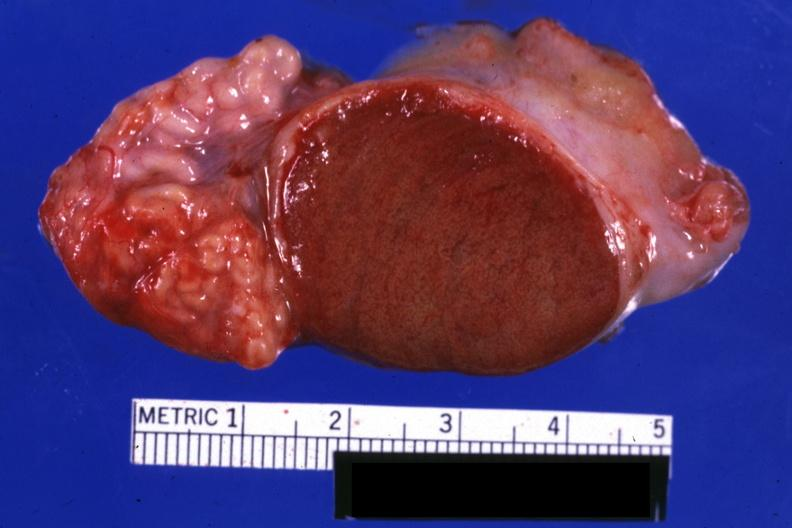what sliced open testicle with intact epididymis?
Answer the question using a single word or phrase. Excellent close-up view 